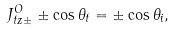Convert formula to latex. <formula><loc_0><loc_0><loc_500><loc_500>J ^ { O } _ { t z \pm } \pm \cos \theta _ { t } = \pm \cos \theta _ { i } ,</formula> 